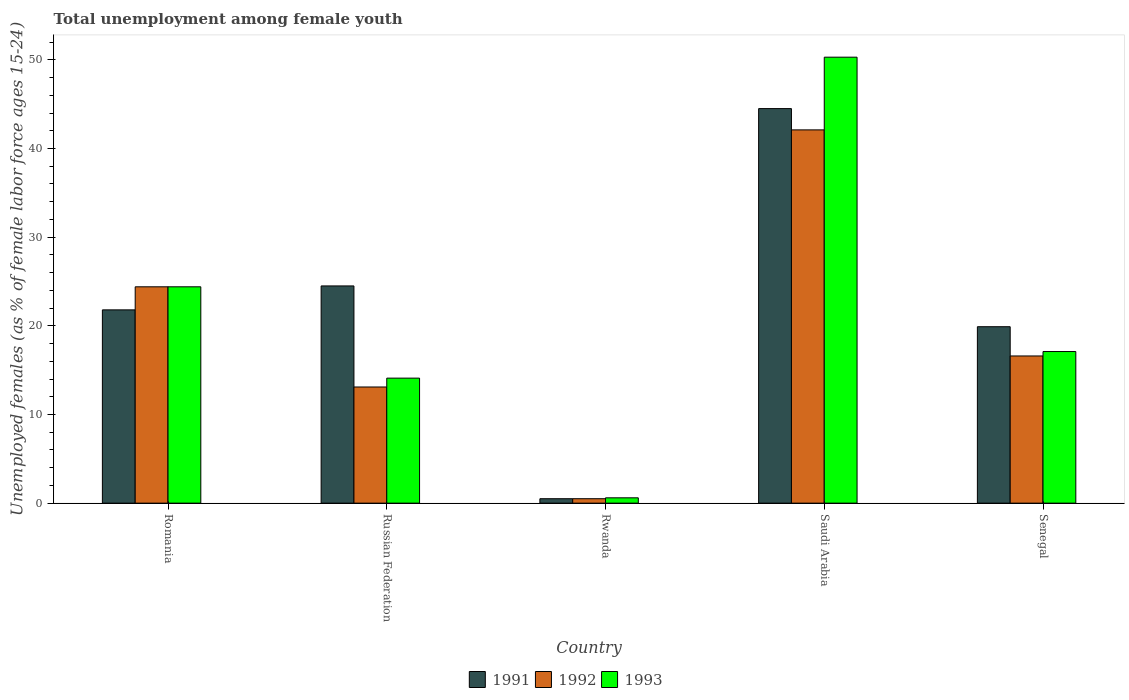How many groups of bars are there?
Give a very brief answer. 5. Are the number of bars per tick equal to the number of legend labels?
Make the answer very short. Yes. Are the number of bars on each tick of the X-axis equal?
Keep it short and to the point. Yes. How many bars are there on the 2nd tick from the left?
Offer a very short reply. 3. What is the label of the 5th group of bars from the left?
Provide a short and direct response. Senegal. What is the percentage of unemployed females in in 1993 in Saudi Arabia?
Keep it short and to the point. 50.3. Across all countries, what is the maximum percentage of unemployed females in in 1991?
Offer a terse response. 44.5. Across all countries, what is the minimum percentage of unemployed females in in 1993?
Provide a short and direct response. 0.6. In which country was the percentage of unemployed females in in 1992 maximum?
Your answer should be compact. Saudi Arabia. In which country was the percentage of unemployed females in in 1991 minimum?
Make the answer very short. Rwanda. What is the total percentage of unemployed females in in 1993 in the graph?
Ensure brevity in your answer.  106.5. What is the difference between the percentage of unemployed females in in 1993 in Romania and that in Senegal?
Ensure brevity in your answer.  7.3. What is the difference between the percentage of unemployed females in in 1991 in Saudi Arabia and the percentage of unemployed females in in 1992 in Rwanda?
Keep it short and to the point. 44. What is the average percentage of unemployed females in in 1992 per country?
Give a very brief answer. 19.34. What is the difference between the percentage of unemployed females in of/in 1993 and percentage of unemployed females in of/in 1992 in Senegal?
Give a very brief answer. 0.5. In how many countries, is the percentage of unemployed females in in 1992 greater than 16 %?
Your answer should be very brief. 3. What is the ratio of the percentage of unemployed females in in 1991 in Romania to that in Senegal?
Keep it short and to the point. 1.1. What is the difference between the highest and the second highest percentage of unemployed females in in 1992?
Offer a terse response. 7.8. What is the difference between the highest and the lowest percentage of unemployed females in in 1991?
Your answer should be compact. 44. In how many countries, is the percentage of unemployed females in in 1993 greater than the average percentage of unemployed females in in 1993 taken over all countries?
Provide a short and direct response. 2. Is the sum of the percentage of unemployed females in in 1991 in Romania and Rwanda greater than the maximum percentage of unemployed females in in 1993 across all countries?
Provide a succinct answer. No. What does the 3rd bar from the left in Rwanda represents?
Keep it short and to the point. 1993. What does the 3rd bar from the right in Romania represents?
Ensure brevity in your answer.  1991. Is it the case that in every country, the sum of the percentage of unemployed females in in 1992 and percentage of unemployed females in in 1991 is greater than the percentage of unemployed females in in 1993?
Offer a terse response. Yes. How many bars are there?
Provide a short and direct response. 15. Are all the bars in the graph horizontal?
Provide a succinct answer. No. How many countries are there in the graph?
Offer a very short reply. 5. What is the difference between two consecutive major ticks on the Y-axis?
Provide a succinct answer. 10. Does the graph contain any zero values?
Your answer should be very brief. No. Does the graph contain grids?
Your answer should be very brief. No. How many legend labels are there?
Your answer should be very brief. 3. How are the legend labels stacked?
Your answer should be very brief. Horizontal. What is the title of the graph?
Make the answer very short. Total unemployment among female youth. Does "2011" appear as one of the legend labels in the graph?
Your answer should be compact. No. What is the label or title of the X-axis?
Provide a succinct answer. Country. What is the label or title of the Y-axis?
Your response must be concise. Unemployed females (as % of female labor force ages 15-24). What is the Unemployed females (as % of female labor force ages 15-24) of 1991 in Romania?
Provide a succinct answer. 21.8. What is the Unemployed females (as % of female labor force ages 15-24) of 1992 in Romania?
Offer a very short reply. 24.4. What is the Unemployed females (as % of female labor force ages 15-24) in 1993 in Romania?
Ensure brevity in your answer.  24.4. What is the Unemployed females (as % of female labor force ages 15-24) in 1991 in Russian Federation?
Your response must be concise. 24.5. What is the Unemployed females (as % of female labor force ages 15-24) in 1992 in Russian Federation?
Make the answer very short. 13.1. What is the Unemployed females (as % of female labor force ages 15-24) in 1993 in Russian Federation?
Your answer should be very brief. 14.1. What is the Unemployed females (as % of female labor force ages 15-24) in 1991 in Rwanda?
Your response must be concise. 0.5. What is the Unemployed females (as % of female labor force ages 15-24) of 1992 in Rwanda?
Offer a terse response. 0.5. What is the Unemployed females (as % of female labor force ages 15-24) of 1993 in Rwanda?
Offer a very short reply. 0.6. What is the Unemployed females (as % of female labor force ages 15-24) in 1991 in Saudi Arabia?
Your answer should be very brief. 44.5. What is the Unemployed females (as % of female labor force ages 15-24) in 1992 in Saudi Arabia?
Give a very brief answer. 42.1. What is the Unemployed females (as % of female labor force ages 15-24) in 1993 in Saudi Arabia?
Your response must be concise. 50.3. What is the Unemployed females (as % of female labor force ages 15-24) in 1991 in Senegal?
Your answer should be very brief. 19.9. What is the Unemployed females (as % of female labor force ages 15-24) in 1992 in Senegal?
Provide a short and direct response. 16.6. What is the Unemployed females (as % of female labor force ages 15-24) of 1993 in Senegal?
Ensure brevity in your answer.  17.1. Across all countries, what is the maximum Unemployed females (as % of female labor force ages 15-24) of 1991?
Your answer should be very brief. 44.5. Across all countries, what is the maximum Unemployed females (as % of female labor force ages 15-24) in 1992?
Your response must be concise. 42.1. Across all countries, what is the maximum Unemployed females (as % of female labor force ages 15-24) of 1993?
Make the answer very short. 50.3. Across all countries, what is the minimum Unemployed females (as % of female labor force ages 15-24) in 1991?
Keep it short and to the point. 0.5. Across all countries, what is the minimum Unemployed females (as % of female labor force ages 15-24) in 1992?
Offer a terse response. 0.5. Across all countries, what is the minimum Unemployed females (as % of female labor force ages 15-24) of 1993?
Provide a short and direct response. 0.6. What is the total Unemployed females (as % of female labor force ages 15-24) of 1991 in the graph?
Provide a succinct answer. 111.2. What is the total Unemployed females (as % of female labor force ages 15-24) in 1992 in the graph?
Your response must be concise. 96.7. What is the total Unemployed females (as % of female labor force ages 15-24) of 1993 in the graph?
Provide a short and direct response. 106.5. What is the difference between the Unemployed females (as % of female labor force ages 15-24) in 1991 in Romania and that in Russian Federation?
Give a very brief answer. -2.7. What is the difference between the Unemployed females (as % of female labor force ages 15-24) in 1992 in Romania and that in Russian Federation?
Provide a short and direct response. 11.3. What is the difference between the Unemployed females (as % of female labor force ages 15-24) of 1991 in Romania and that in Rwanda?
Keep it short and to the point. 21.3. What is the difference between the Unemployed females (as % of female labor force ages 15-24) in 1992 in Romania and that in Rwanda?
Your answer should be compact. 23.9. What is the difference between the Unemployed females (as % of female labor force ages 15-24) of 1993 in Romania and that in Rwanda?
Offer a terse response. 23.8. What is the difference between the Unemployed females (as % of female labor force ages 15-24) in 1991 in Romania and that in Saudi Arabia?
Your answer should be very brief. -22.7. What is the difference between the Unemployed females (as % of female labor force ages 15-24) in 1992 in Romania and that in Saudi Arabia?
Give a very brief answer. -17.7. What is the difference between the Unemployed females (as % of female labor force ages 15-24) in 1993 in Romania and that in Saudi Arabia?
Keep it short and to the point. -25.9. What is the difference between the Unemployed females (as % of female labor force ages 15-24) of 1991 in Russian Federation and that in Rwanda?
Keep it short and to the point. 24. What is the difference between the Unemployed females (as % of female labor force ages 15-24) in 1992 in Russian Federation and that in Rwanda?
Keep it short and to the point. 12.6. What is the difference between the Unemployed females (as % of female labor force ages 15-24) of 1993 in Russian Federation and that in Rwanda?
Your answer should be very brief. 13.5. What is the difference between the Unemployed females (as % of female labor force ages 15-24) of 1993 in Russian Federation and that in Saudi Arabia?
Give a very brief answer. -36.2. What is the difference between the Unemployed females (as % of female labor force ages 15-24) of 1991 in Russian Federation and that in Senegal?
Keep it short and to the point. 4.6. What is the difference between the Unemployed females (as % of female labor force ages 15-24) in 1993 in Russian Federation and that in Senegal?
Your answer should be very brief. -3. What is the difference between the Unemployed females (as % of female labor force ages 15-24) of 1991 in Rwanda and that in Saudi Arabia?
Ensure brevity in your answer.  -44. What is the difference between the Unemployed females (as % of female labor force ages 15-24) in 1992 in Rwanda and that in Saudi Arabia?
Offer a terse response. -41.6. What is the difference between the Unemployed females (as % of female labor force ages 15-24) of 1993 in Rwanda and that in Saudi Arabia?
Ensure brevity in your answer.  -49.7. What is the difference between the Unemployed females (as % of female labor force ages 15-24) in 1991 in Rwanda and that in Senegal?
Ensure brevity in your answer.  -19.4. What is the difference between the Unemployed females (as % of female labor force ages 15-24) of 1992 in Rwanda and that in Senegal?
Give a very brief answer. -16.1. What is the difference between the Unemployed females (as % of female labor force ages 15-24) of 1993 in Rwanda and that in Senegal?
Provide a short and direct response. -16.5. What is the difference between the Unemployed females (as % of female labor force ages 15-24) of 1991 in Saudi Arabia and that in Senegal?
Your answer should be very brief. 24.6. What is the difference between the Unemployed females (as % of female labor force ages 15-24) of 1993 in Saudi Arabia and that in Senegal?
Your response must be concise. 33.2. What is the difference between the Unemployed females (as % of female labor force ages 15-24) of 1991 in Romania and the Unemployed females (as % of female labor force ages 15-24) of 1992 in Russian Federation?
Your answer should be very brief. 8.7. What is the difference between the Unemployed females (as % of female labor force ages 15-24) of 1992 in Romania and the Unemployed females (as % of female labor force ages 15-24) of 1993 in Russian Federation?
Ensure brevity in your answer.  10.3. What is the difference between the Unemployed females (as % of female labor force ages 15-24) of 1991 in Romania and the Unemployed females (as % of female labor force ages 15-24) of 1992 in Rwanda?
Your answer should be compact. 21.3. What is the difference between the Unemployed females (as % of female labor force ages 15-24) of 1991 in Romania and the Unemployed females (as % of female labor force ages 15-24) of 1993 in Rwanda?
Your response must be concise. 21.2. What is the difference between the Unemployed females (as % of female labor force ages 15-24) in 1992 in Romania and the Unemployed females (as % of female labor force ages 15-24) in 1993 in Rwanda?
Your answer should be very brief. 23.8. What is the difference between the Unemployed females (as % of female labor force ages 15-24) in 1991 in Romania and the Unemployed females (as % of female labor force ages 15-24) in 1992 in Saudi Arabia?
Provide a succinct answer. -20.3. What is the difference between the Unemployed females (as % of female labor force ages 15-24) of 1991 in Romania and the Unemployed females (as % of female labor force ages 15-24) of 1993 in Saudi Arabia?
Provide a succinct answer. -28.5. What is the difference between the Unemployed females (as % of female labor force ages 15-24) in 1992 in Romania and the Unemployed females (as % of female labor force ages 15-24) in 1993 in Saudi Arabia?
Provide a short and direct response. -25.9. What is the difference between the Unemployed females (as % of female labor force ages 15-24) of 1992 in Romania and the Unemployed females (as % of female labor force ages 15-24) of 1993 in Senegal?
Keep it short and to the point. 7.3. What is the difference between the Unemployed females (as % of female labor force ages 15-24) in 1991 in Russian Federation and the Unemployed females (as % of female labor force ages 15-24) in 1992 in Rwanda?
Give a very brief answer. 24. What is the difference between the Unemployed females (as % of female labor force ages 15-24) in 1991 in Russian Federation and the Unemployed females (as % of female labor force ages 15-24) in 1993 in Rwanda?
Your response must be concise. 23.9. What is the difference between the Unemployed females (as % of female labor force ages 15-24) in 1991 in Russian Federation and the Unemployed females (as % of female labor force ages 15-24) in 1992 in Saudi Arabia?
Offer a very short reply. -17.6. What is the difference between the Unemployed females (as % of female labor force ages 15-24) of 1991 in Russian Federation and the Unemployed females (as % of female labor force ages 15-24) of 1993 in Saudi Arabia?
Provide a short and direct response. -25.8. What is the difference between the Unemployed females (as % of female labor force ages 15-24) of 1992 in Russian Federation and the Unemployed females (as % of female labor force ages 15-24) of 1993 in Saudi Arabia?
Provide a short and direct response. -37.2. What is the difference between the Unemployed females (as % of female labor force ages 15-24) of 1992 in Russian Federation and the Unemployed females (as % of female labor force ages 15-24) of 1993 in Senegal?
Keep it short and to the point. -4. What is the difference between the Unemployed females (as % of female labor force ages 15-24) in 1991 in Rwanda and the Unemployed females (as % of female labor force ages 15-24) in 1992 in Saudi Arabia?
Ensure brevity in your answer.  -41.6. What is the difference between the Unemployed females (as % of female labor force ages 15-24) of 1991 in Rwanda and the Unemployed females (as % of female labor force ages 15-24) of 1993 in Saudi Arabia?
Your response must be concise. -49.8. What is the difference between the Unemployed females (as % of female labor force ages 15-24) of 1992 in Rwanda and the Unemployed females (as % of female labor force ages 15-24) of 1993 in Saudi Arabia?
Offer a very short reply. -49.8. What is the difference between the Unemployed females (as % of female labor force ages 15-24) of 1991 in Rwanda and the Unemployed females (as % of female labor force ages 15-24) of 1992 in Senegal?
Keep it short and to the point. -16.1. What is the difference between the Unemployed females (as % of female labor force ages 15-24) of 1991 in Rwanda and the Unemployed females (as % of female labor force ages 15-24) of 1993 in Senegal?
Your response must be concise. -16.6. What is the difference between the Unemployed females (as % of female labor force ages 15-24) of 1992 in Rwanda and the Unemployed females (as % of female labor force ages 15-24) of 1993 in Senegal?
Ensure brevity in your answer.  -16.6. What is the difference between the Unemployed females (as % of female labor force ages 15-24) of 1991 in Saudi Arabia and the Unemployed females (as % of female labor force ages 15-24) of 1992 in Senegal?
Offer a terse response. 27.9. What is the difference between the Unemployed females (as % of female labor force ages 15-24) of 1991 in Saudi Arabia and the Unemployed females (as % of female labor force ages 15-24) of 1993 in Senegal?
Your answer should be very brief. 27.4. What is the difference between the Unemployed females (as % of female labor force ages 15-24) of 1992 in Saudi Arabia and the Unemployed females (as % of female labor force ages 15-24) of 1993 in Senegal?
Keep it short and to the point. 25. What is the average Unemployed females (as % of female labor force ages 15-24) in 1991 per country?
Provide a succinct answer. 22.24. What is the average Unemployed females (as % of female labor force ages 15-24) in 1992 per country?
Your response must be concise. 19.34. What is the average Unemployed females (as % of female labor force ages 15-24) in 1993 per country?
Make the answer very short. 21.3. What is the difference between the Unemployed females (as % of female labor force ages 15-24) in 1991 and Unemployed females (as % of female labor force ages 15-24) in 1992 in Romania?
Offer a very short reply. -2.6. What is the difference between the Unemployed females (as % of female labor force ages 15-24) in 1991 and Unemployed females (as % of female labor force ages 15-24) in 1992 in Russian Federation?
Offer a very short reply. 11.4. What is the difference between the Unemployed females (as % of female labor force ages 15-24) of 1991 and Unemployed females (as % of female labor force ages 15-24) of 1993 in Russian Federation?
Provide a succinct answer. 10.4. What is the difference between the Unemployed females (as % of female labor force ages 15-24) of 1991 and Unemployed females (as % of female labor force ages 15-24) of 1992 in Saudi Arabia?
Offer a terse response. 2.4. What is the difference between the Unemployed females (as % of female labor force ages 15-24) of 1991 and Unemployed females (as % of female labor force ages 15-24) of 1993 in Senegal?
Offer a terse response. 2.8. What is the ratio of the Unemployed females (as % of female labor force ages 15-24) in 1991 in Romania to that in Russian Federation?
Your answer should be compact. 0.89. What is the ratio of the Unemployed females (as % of female labor force ages 15-24) of 1992 in Romania to that in Russian Federation?
Make the answer very short. 1.86. What is the ratio of the Unemployed females (as % of female labor force ages 15-24) in 1993 in Romania to that in Russian Federation?
Your answer should be compact. 1.73. What is the ratio of the Unemployed females (as % of female labor force ages 15-24) in 1991 in Romania to that in Rwanda?
Provide a short and direct response. 43.6. What is the ratio of the Unemployed females (as % of female labor force ages 15-24) of 1992 in Romania to that in Rwanda?
Provide a succinct answer. 48.8. What is the ratio of the Unemployed females (as % of female labor force ages 15-24) in 1993 in Romania to that in Rwanda?
Your answer should be very brief. 40.67. What is the ratio of the Unemployed females (as % of female labor force ages 15-24) in 1991 in Romania to that in Saudi Arabia?
Keep it short and to the point. 0.49. What is the ratio of the Unemployed females (as % of female labor force ages 15-24) of 1992 in Romania to that in Saudi Arabia?
Offer a terse response. 0.58. What is the ratio of the Unemployed females (as % of female labor force ages 15-24) in 1993 in Romania to that in Saudi Arabia?
Offer a very short reply. 0.49. What is the ratio of the Unemployed females (as % of female labor force ages 15-24) in 1991 in Romania to that in Senegal?
Offer a terse response. 1.1. What is the ratio of the Unemployed females (as % of female labor force ages 15-24) in 1992 in Romania to that in Senegal?
Keep it short and to the point. 1.47. What is the ratio of the Unemployed females (as % of female labor force ages 15-24) of 1993 in Romania to that in Senegal?
Keep it short and to the point. 1.43. What is the ratio of the Unemployed females (as % of female labor force ages 15-24) in 1991 in Russian Federation to that in Rwanda?
Offer a very short reply. 49. What is the ratio of the Unemployed females (as % of female labor force ages 15-24) in 1992 in Russian Federation to that in Rwanda?
Provide a succinct answer. 26.2. What is the ratio of the Unemployed females (as % of female labor force ages 15-24) in 1991 in Russian Federation to that in Saudi Arabia?
Give a very brief answer. 0.55. What is the ratio of the Unemployed females (as % of female labor force ages 15-24) of 1992 in Russian Federation to that in Saudi Arabia?
Offer a terse response. 0.31. What is the ratio of the Unemployed females (as % of female labor force ages 15-24) of 1993 in Russian Federation to that in Saudi Arabia?
Your response must be concise. 0.28. What is the ratio of the Unemployed females (as % of female labor force ages 15-24) of 1991 in Russian Federation to that in Senegal?
Offer a very short reply. 1.23. What is the ratio of the Unemployed females (as % of female labor force ages 15-24) in 1992 in Russian Federation to that in Senegal?
Your answer should be compact. 0.79. What is the ratio of the Unemployed females (as % of female labor force ages 15-24) of 1993 in Russian Federation to that in Senegal?
Make the answer very short. 0.82. What is the ratio of the Unemployed females (as % of female labor force ages 15-24) of 1991 in Rwanda to that in Saudi Arabia?
Offer a very short reply. 0.01. What is the ratio of the Unemployed females (as % of female labor force ages 15-24) in 1992 in Rwanda to that in Saudi Arabia?
Offer a very short reply. 0.01. What is the ratio of the Unemployed females (as % of female labor force ages 15-24) in 1993 in Rwanda to that in Saudi Arabia?
Your answer should be compact. 0.01. What is the ratio of the Unemployed females (as % of female labor force ages 15-24) of 1991 in Rwanda to that in Senegal?
Provide a succinct answer. 0.03. What is the ratio of the Unemployed females (as % of female labor force ages 15-24) in 1992 in Rwanda to that in Senegal?
Provide a short and direct response. 0.03. What is the ratio of the Unemployed females (as % of female labor force ages 15-24) in 1993 in Rwanda to that in Senegal?
Make the answer very short. 0.04. What is the ratio of the Unemployed females (as % of female labor force ages 15-24) of 1991 in Saudi Arabia to that in Senegal?
Keep it short and to the point. 2.24. What is the ratio of the Unemployed females (as % of female labor force ages 15-24) in 1992 in Saudi Arabia to that in Senegal?
Offer a terse response. 2.54. What is the ratio of the Unemployed females (as % of female labor force ages 15-24) of 1993 in Saudi Arabia to that in Senegal?
Offer a terse response. 2.94. What is the difference between the highest and the second highest Unemployed females (as % of female labor force ages 15-24) in 1991?
Keep it short and to the point. 20. What is the difference between the highest and the second highest Unemployed females (as % of female labor force ages 15-24) in 1993?
Your answer should be very brief. 25.9. What is the difference between the highest and the lowest Unemployed females (as % of female labor force ages 15-24) in 1991?
Keep it short and to the point. 44. What is the difference between the highest and the lowest Unemployed females (as % of female labor force ages 15-24) of 1992?
Provide a short and direct response. 41.6. What is the difference between the highest and the lowest Unemployed females (as % of female labor force ages 15-24) of 1993?
Your answer should be very brief. 49.7. 